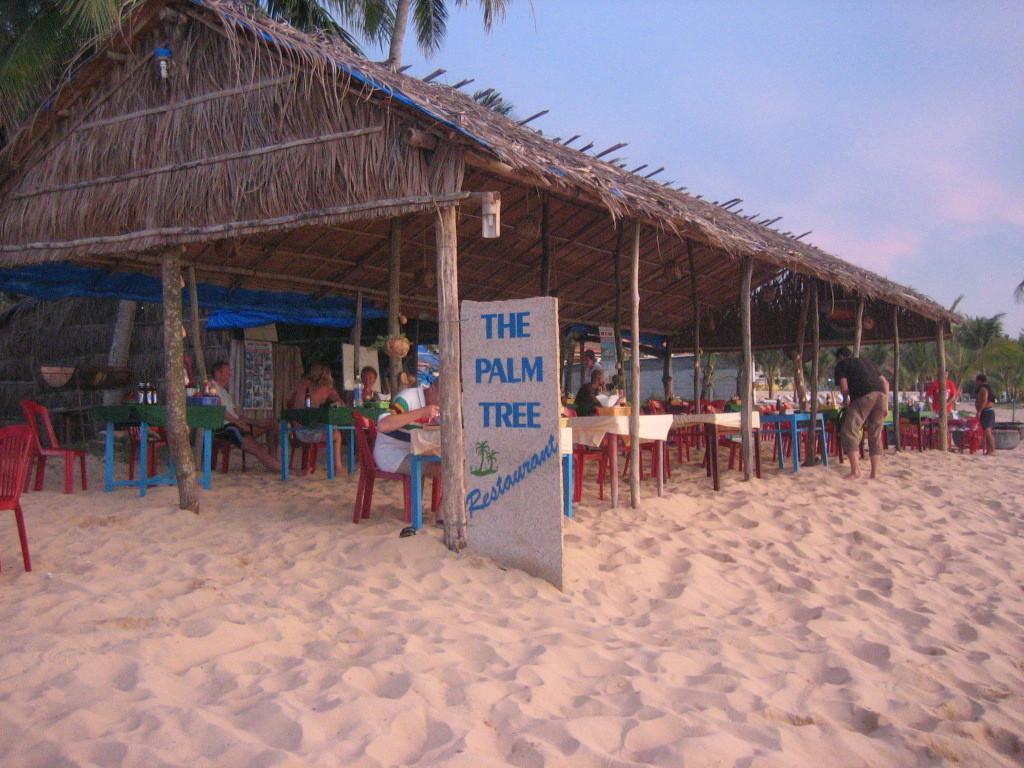Can you describe this image briefly? In this image I can see few people some are standing and some are sitting on the chairs. I can also see shed in brown color, trees in green color and sky in blue color. 